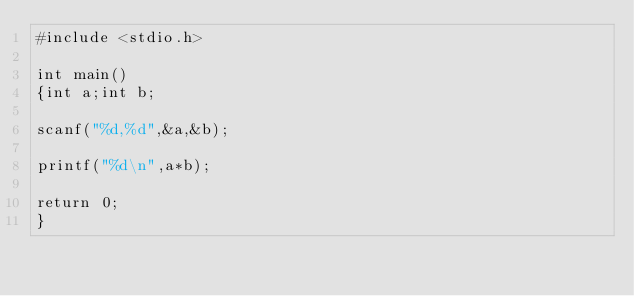<code> <loc_0><loc_0><loc_500><loc_500><_C_>#include <stdio.h>

int main()
{int a;int b;

scanf("%d,%d",&a,&b);

printf("%d\n",a*b);

return 0;
}</code> 